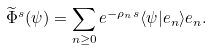Convert formula to latex. <formula><loc_0><loc_0><loc_500><loc_500>\widetilde { \Phi } ^ { s } ( \psi ) = \sum _ { n \geq 0 } e ^ { - \rho _ { n } s } \langle \psi | e _ { n } \rangle e _ { n } .</formula> 